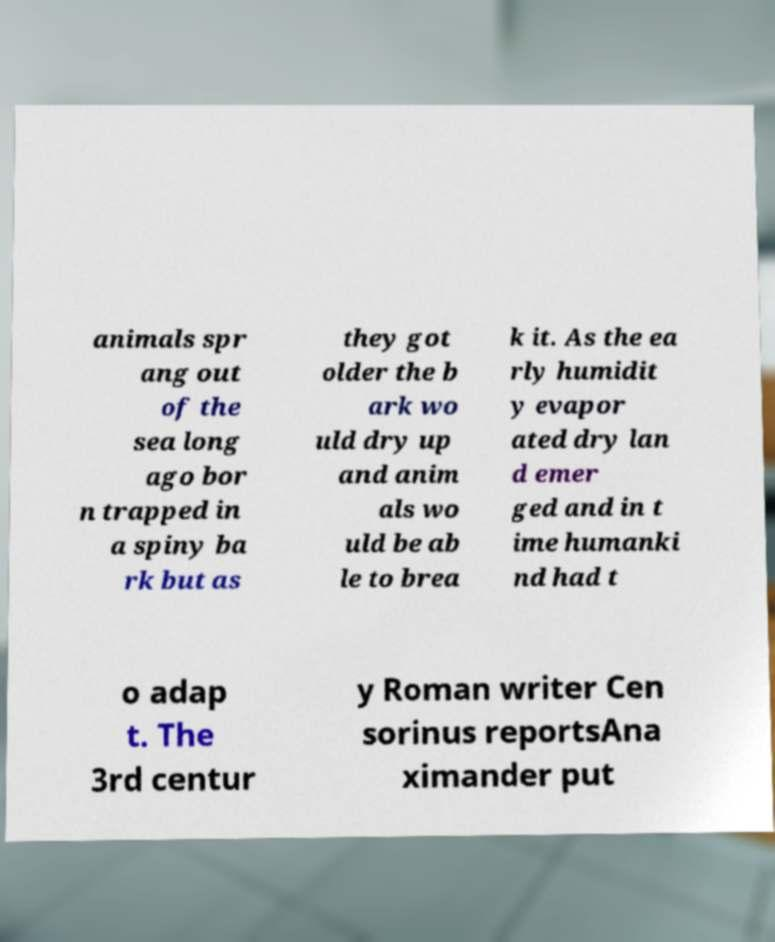Can you accurately transcribe the text from the provided image for me? animals spr ang out of the sea long ago bor n trapped in a spiny ba rk but as they got older the b ark wo uld dry up and anim als wo uld be ab le to brea k it. As the ea rly humidit y evapor ated dry lan d emer ged and in t ime humanki nd had t o adap t. The 3rd centur y Roman writer Cen sorinus reportsAna ximander put 